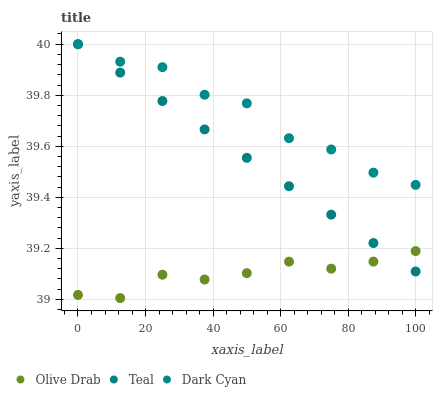Does Olive Drab have the minimum area under the curve?
Answer yes or no. Yes. Does Dark Cyan have the maximum area under the curve?
Answer yes or no. Yes. Does Teal have the minimum area under the curve?
Answer yes or no. No. Does Teal have the maximum area under the curve?
Answer yes or no. No. Is Teal the smoothest?
Answer yes or no. Yes. Is Dark Cyan the roughest?
Answer yes or no. Yes. Is Olive Drab the smoothest?
Answer yes or no. No. Is Olive Drab the roughest?
Answer yes or no. No. Does Olive Drab have the lowest value?
Answer yes or no. Yes. Does Teal have the lowest value?
Answer yes or no. No. Does Teal have the highest value?
Answer yes or no. Yes. Does Olive Drab have the highest value?
Answer yes or no. No. Is Olive Drab less than Dark Cyan?
Answer yes or no. Yes. Is Dark Cyan greater than Olive Drab?
Answer yes or no. Yes. Does Teal intersect Dark Cyan?
Answer yes or no. Yes. Is Teal less than Dark Cyan?
Answer yes or no. No. Is Teal greater than Dark Cyan?
Answer yes or no. No. Does Olive Drab intersect Dark Cyan?
Answer yes or no. No. 